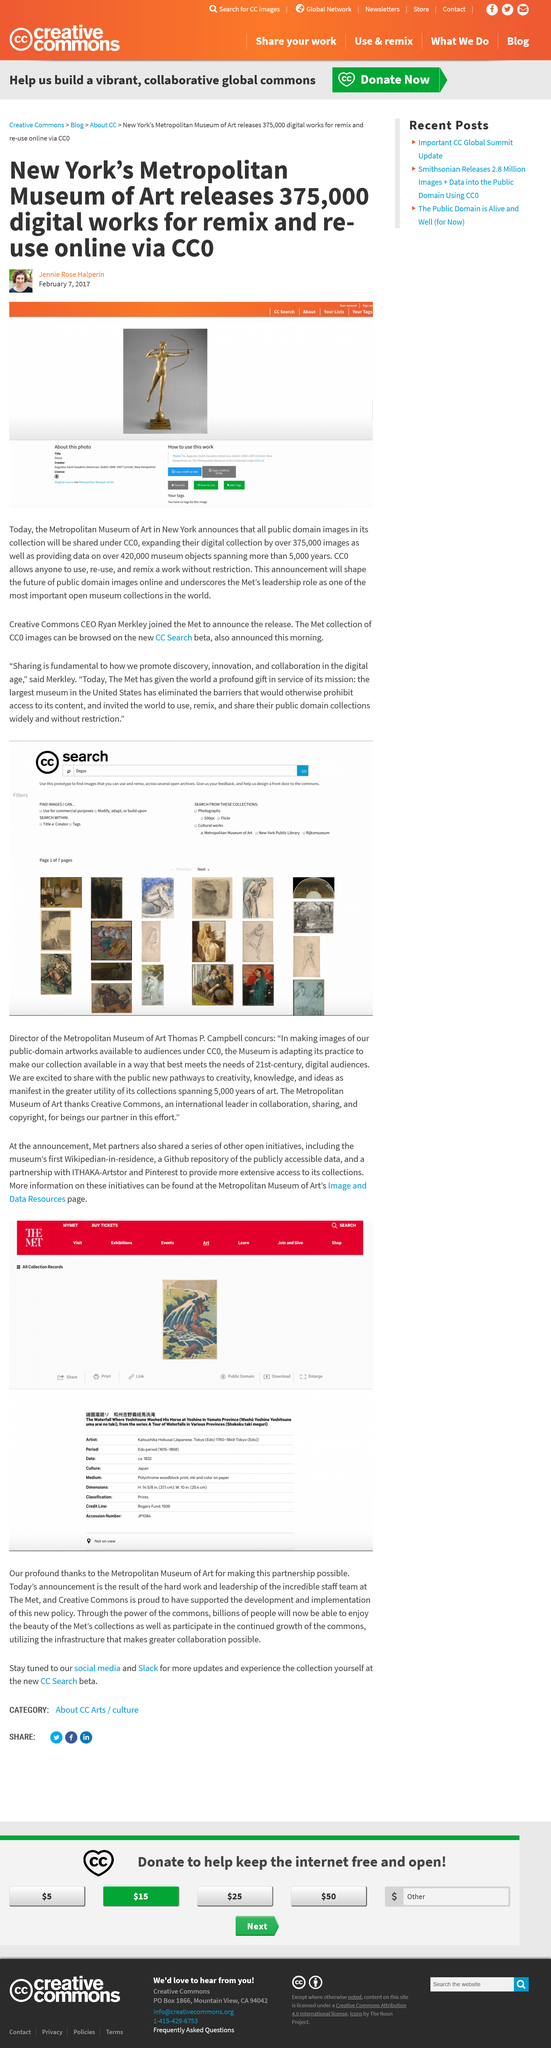Outline some significant characteristics in this image. The Museum is widely regarded as one of the most significant open museum collections in the world. The images were released for use on February 7, 2017. I used CC0 to share the images, which is a public domain dedication tool that allows for the free use and modification of the shared content. 